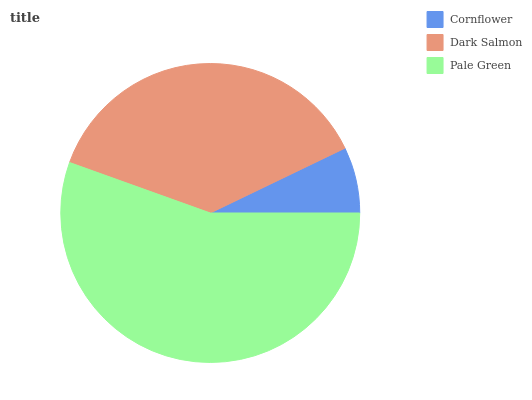Is Cornflower the minimum?
Answer yes or no. Yes. Is Pale Green the maximum?
Answer yes or no. Yes. Is Dark Salmon the minimum?
Answer yes or no. No. Is Dark Salmon the maximum?
Answer yes or no. No. Is Dark Salmon greater than Cornflower?
Answer yes or no. Yes. Is Cornflower less than Dark Salmon?
Answer yes or no. Yes. Is Cornflower greater than Dark Salmon?
Answer yes or no. No. Is Dark Salmon less than Cornflower?
Answer yes or no. No. Is Dark Salmon the high median?
Answer yes or no. Yes. Is Dark Salmon the low median?
Answer yes or no. Yes. Is Pale Green the high median?
Answer yes or no. No. Is Pale Green the low median?
Answer yes or no. No. 